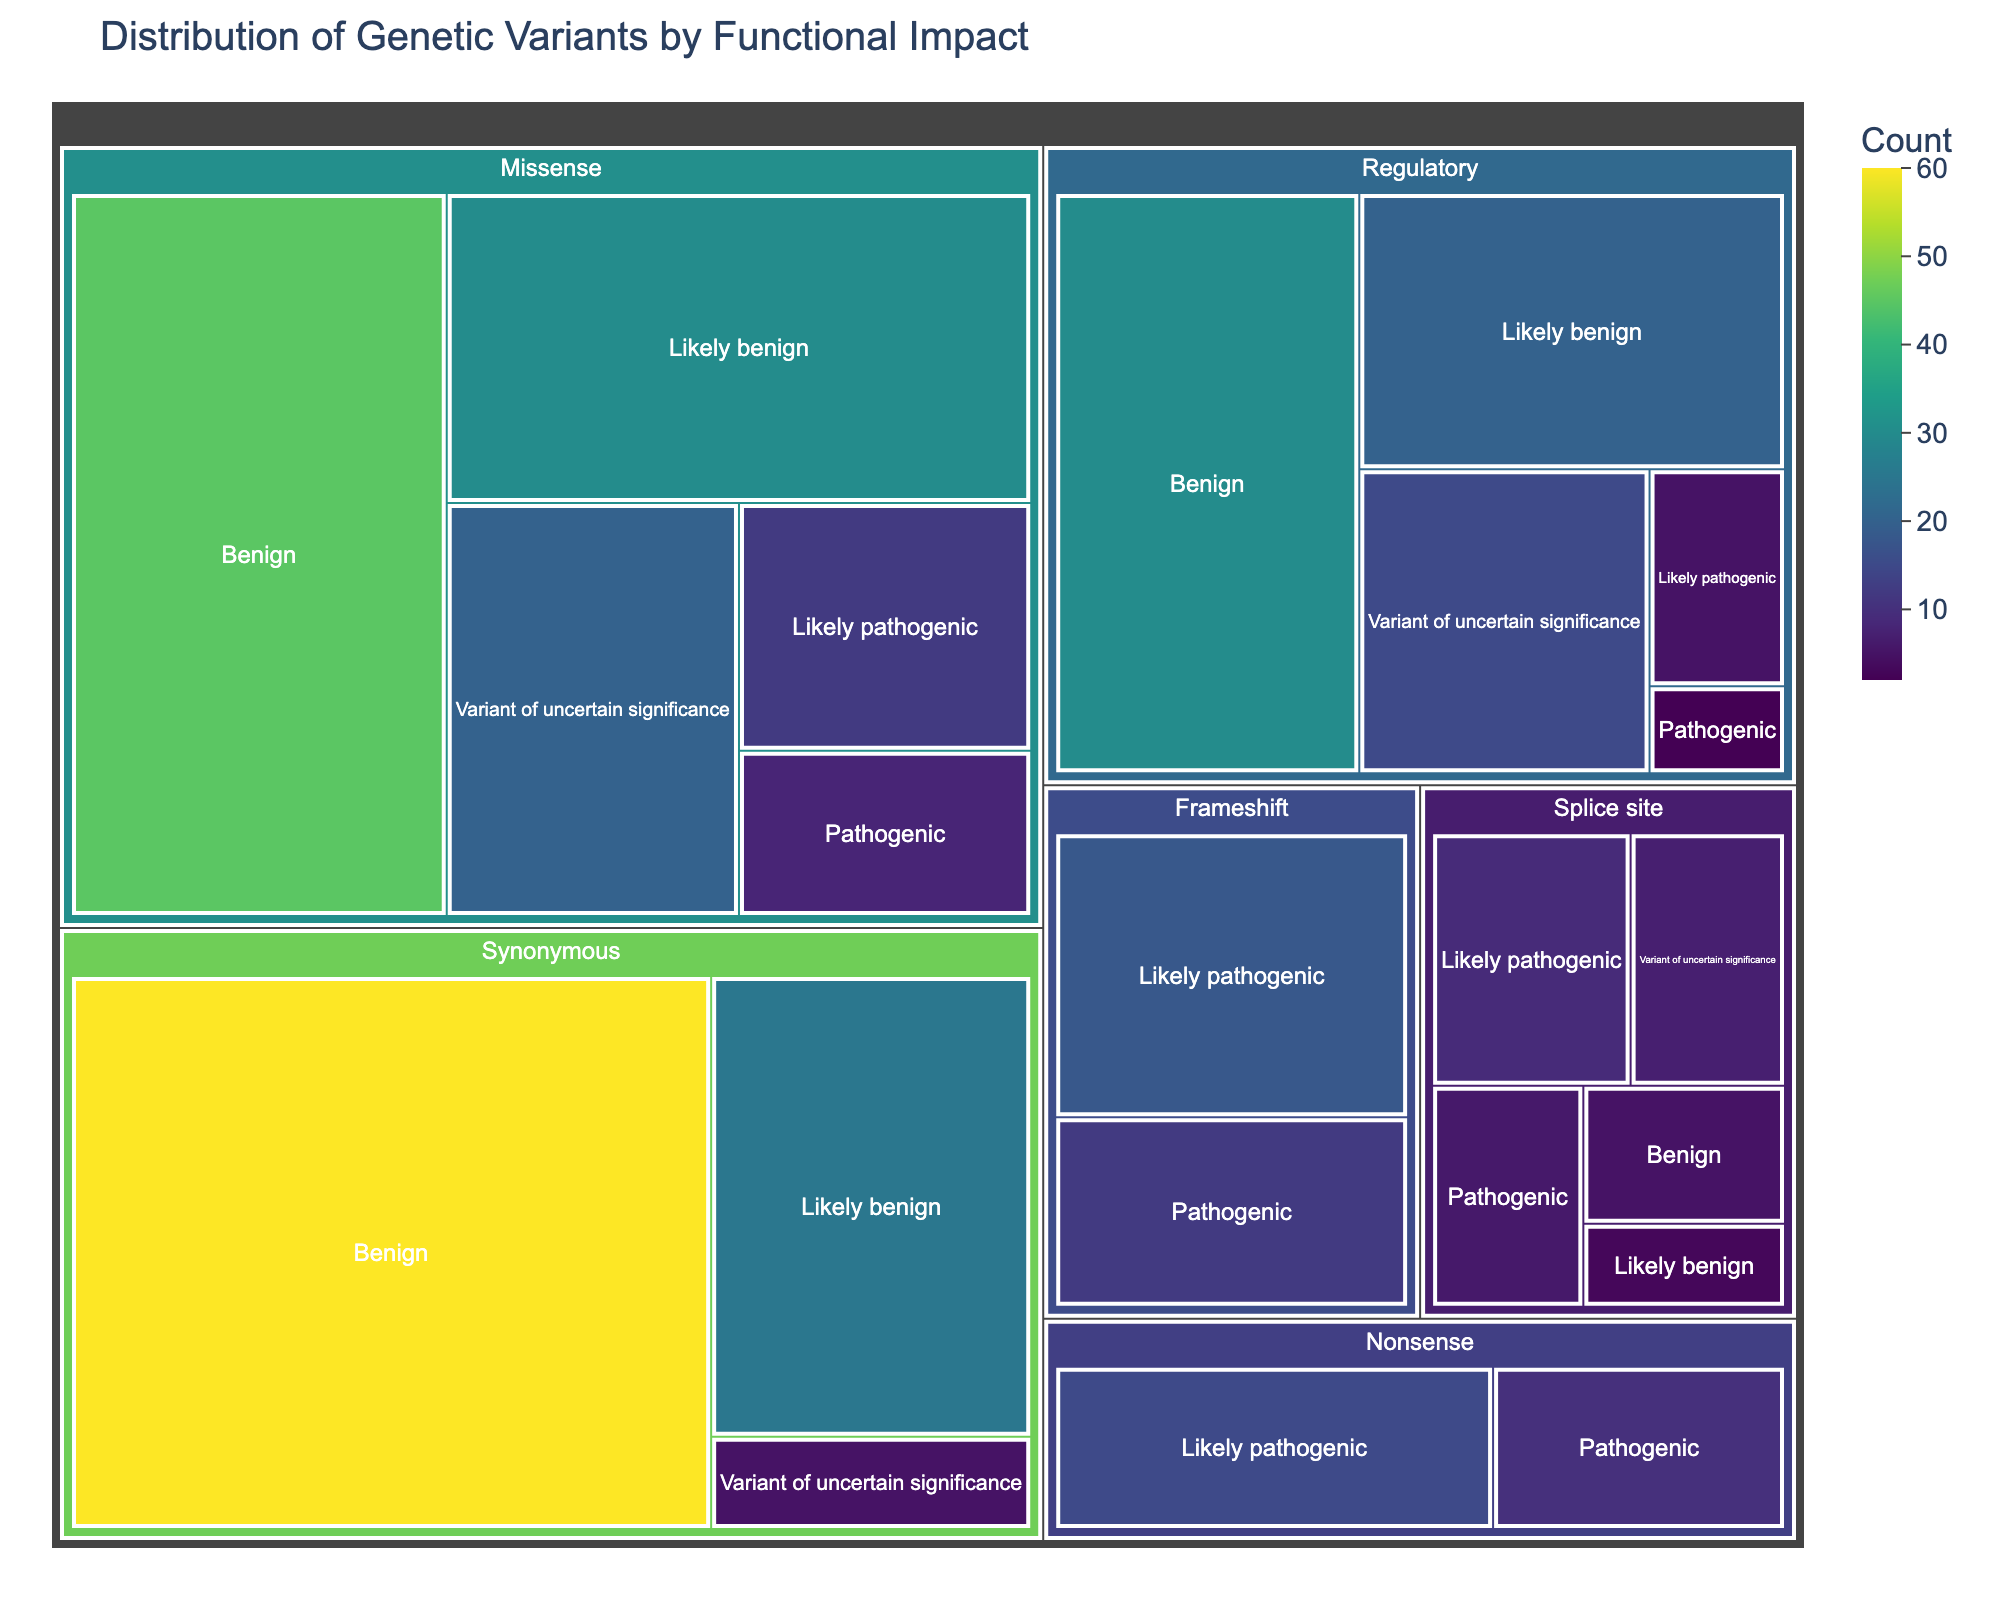Which functional impact category has the highest total count of genetic variants? To determine the category with the highest total count, sum the counts of all subcategories within each category, then compare across categories.
Answer: Missense How many genetic variants are classified as regulatory? Sum the counts of all subcategories under the "Regulatory" category: 30 (Benign) + 20 (Likely benign) + 15 (Variant of uncertain significance) + 5 (Likely pathogenic) + 2 (Pathogenic).
Answer: 72 Which subcategory under "Synonymous" has the lowest count, and what is its value? Identify the subcategory with the smallest value under "Synonymous" by comparing the values: Benign (60), Likely benign (25), Variant of uncertain significance (5). The smallest value is 5.
Answer: Variant of uncertain significance, 5 Count the total number of 'Likely pathogenic' variants across all categories. Add the values of 'Likely pathogenic' for all categories: Missense (12), Nonsense (15), Frameshift (18), Splice site (9), Regulatory (5).
Answer: 59 Compare the counts of "Pathogenic" variants between "Missense" and "Frameshift". Which one is higher? Compare the values of "Pathogenic" for both categories: Missense (8) and Frameshift (12). The higher value is for Frameshift.
Answer: Frameshift What is the combined count of benign variants across all categories? Sum the counts of all benign subcategories: Missense (45), Splice site (5), Synonymous (60), Regulatory (30).
Answer: 140 How does the count of "Variant of uncertain significance" in the "Regulatory" category compare to that in the "Missense" category? Compare the counts: Regulatory (15) and Missense (20). The missense category has a higher count.
Answer: Missense has a higher count Are there more "Likely benign" variants in "Synonymous" or in "Missense"? Compare the counts of "Likely benign": Synonymous (25) versus Missense (30). Missense has more.
Answer: Missense Which category has the fewest total "Pathogenic" variants, and what is the count? Calculate the total count of "Pathogenic" for each category: Missense (8), Nonsense (10), Frameshift (12), Splice site (6), Regulatory (2). The smallest count is for Regulatory.
Answer: Regulatory, 2 Explain how the color gradient in the treemap helps in interpreting the data. The color gradient (viridis scale) indicates the count of variants, with lighter shades representing higher counts and darker shades representing lower counts. This helps in quickly identifying areas with more or fewer variants.
Answer: Uses color intensity to indicate count 